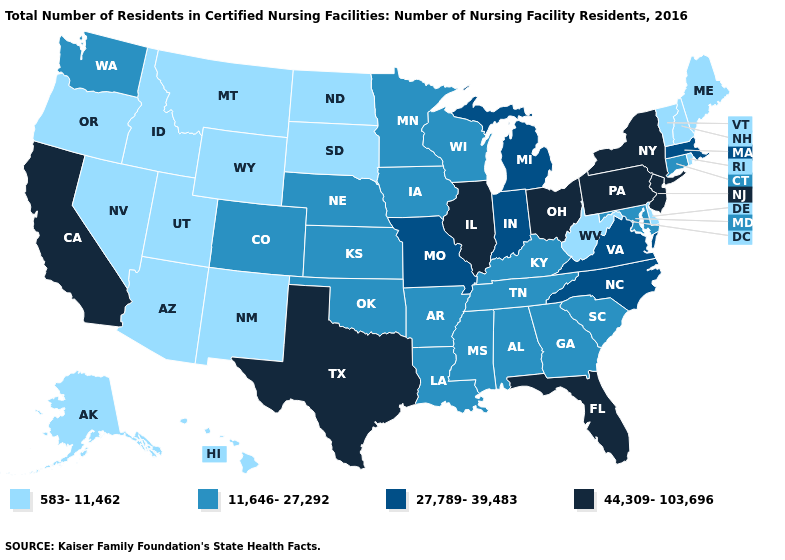What is the highest value in the West ?
Be succinct. 44,309-103,696. What is the value of New Jersey?
Answer briefly. 44,309-103,696. Among the states that border North Dakota , does South Dakota have the highest value?
Write a very short answer. No. What is the lowest value in the MidWest?
Answer briefly. 583-11,462. Among the states that border Pennsylvania , does New York have the lowest value?
Concise answer only. No. What is the highest value in the USA?
Give a very brief answer. 44,309-103,696. What is the value of Colorado?
Be succinct. 11,646-27,292. What is the lowest value in the USA?
Answer briefly. 583-11,462. What is the value of Arizona?
Be succinct. 583-11,462. What is the value of Minnesota?
Short answer required. 11,646-27,292. Among the states that border Connecticut , does Massachusetts have the highest value?
Short answer required. No. Which states hav the highest value in the South?
Answer briefly. Florida, Texas. What is the value of Washington?
Short answer required. 11,646-27,292. Name the states that have a value in the range 27,789-39,483?
Write a very short answer. Indiana, Massachusetts, Michigan, Missouri, North Carolina, Virginia. What is the highest value in the South ?
Answer briefly. 44,309-103,696. 